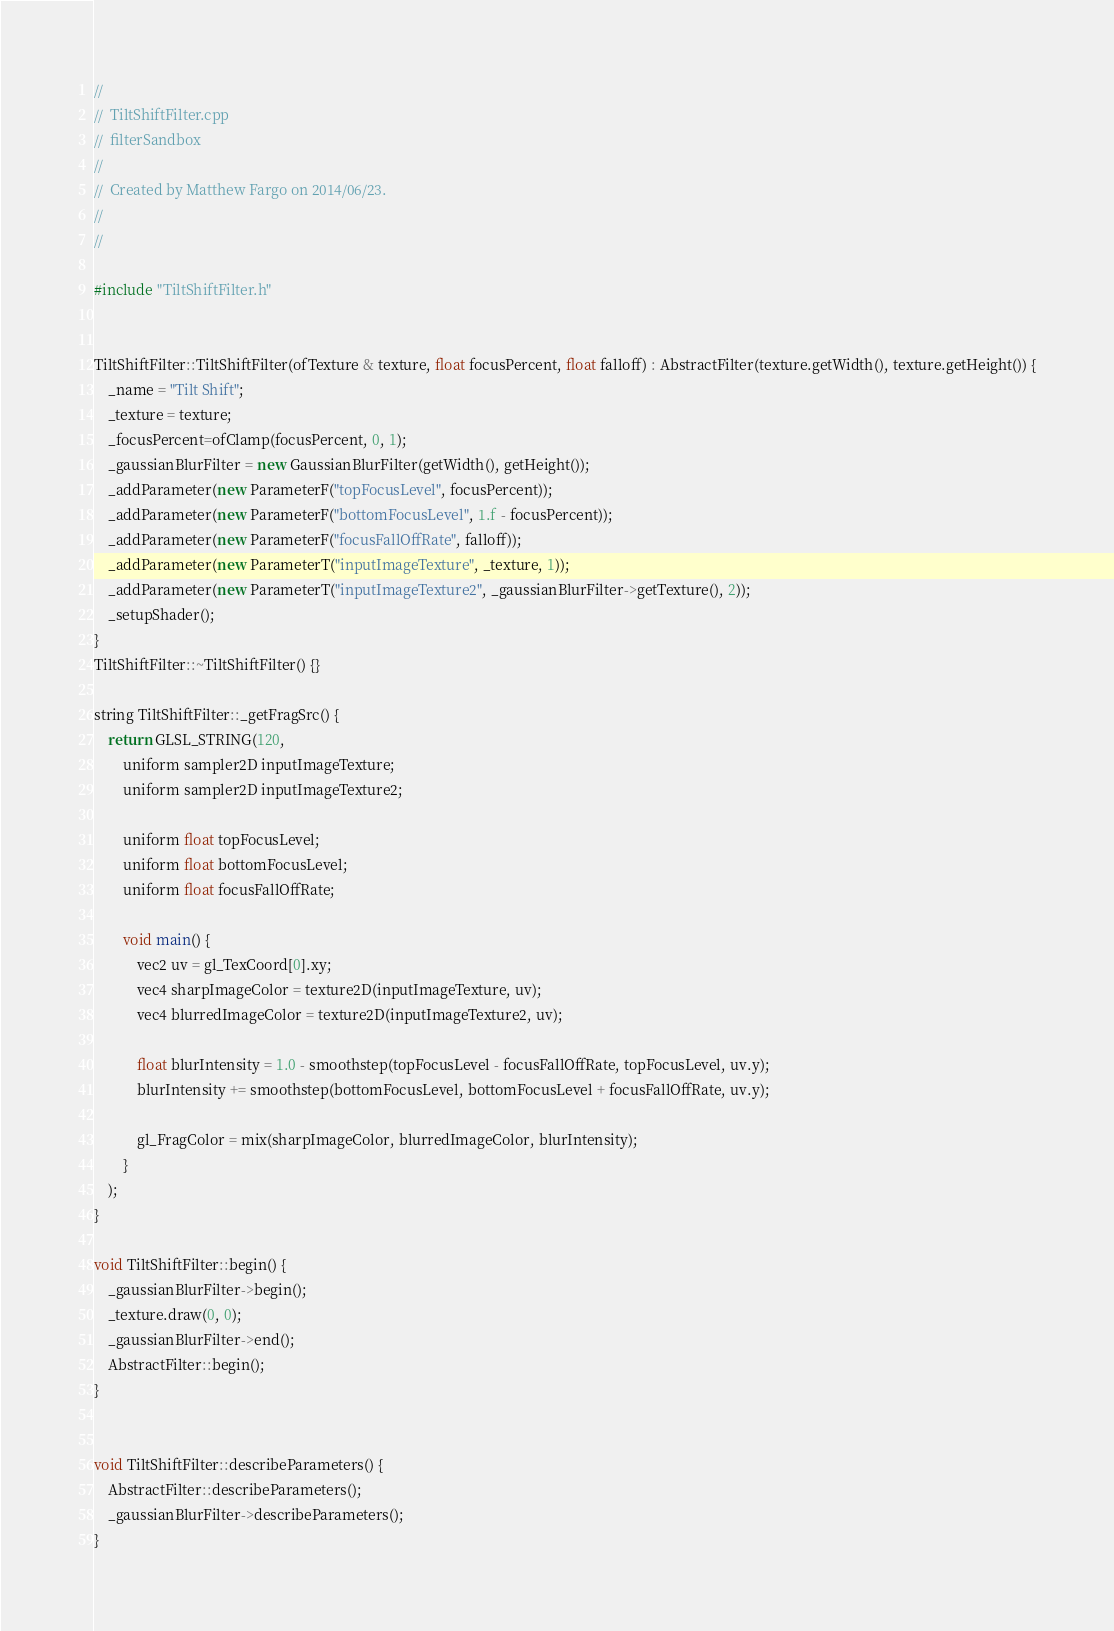Convert code to text. <code><loc_0><loc_0><loc_500><loc_500><_C++_>//
//  TiltShiftFilter.cpp
//  filterSandbox
//
//  Created by Matthew Fargo on 2014/06/23.
//
//

#include "TiltShiftFilter.h"


TiltShiftFilter::TiltShiftFilter(ofTexture & texture, float focusPercent, float falloff) : AbstractFilter(texture.getWidth(), texture.getHeight()) {
    _name = "Tilt Shift";
    _texture = texture;
    _focusPercent=ofClamp(focusPercent, 0, 1);
    _gaussianBlurFilter = new GaussianBlurFilter(getWidth(), getHeight());
    _addParameter(new ParameterF("topFocusLevel", focusPercent));
    _addParameter(new ParameterF("bottomFocusLevel", 1.f - focusPercent));
    _addParameter(new ParameterF("focusFallOffRate", falloff));
    _addParameter(new ParameterT("inputImageTexture", _texture, 1));
    _addParameter(new ParameterT("inputImageTexture2", _gaussianBlurFilter->getTexture(), 2));
    _setupShader();
}
TiltShiftFilter::~TiltShiftFilter() {}

string TiltShiftFilter::_getFragSrc() {
    return GLSL_STRING(120,
        uniform sampler2D inputImageTexture;
        uniform sampler2D inputImageTexture2;

        uniform float topFocusLevel;
        uniform float bottomFocusLevel;
        uniform float focusFallOffRate;

        void main() {
            vec2 uv = gl_TexCoord[0].xy;
            vec4 sharpImageColor = texture2D(inputImageTexture, uv);
            vec4 blurredImageColor = texture2D(inputImageTexture2, uv);
            
            float blurIntensity = 1.0 - smoothstep(topFocusLevel - focusFallOffRate, topFocusLevel, uv.y);
            blurIntensity += smoothstep(bottomFocusLevel, bottomFocusLevel + focusFallOffRate, uv.y);
            
            gl_FragColor = mix(sharpImageColor, blurredImageColor, blurIntensity);
        }
    );
}

void TiltShiftFilter::begin() {
    _gaussianBlurFilter->begin();
    _texture.draw(0, 0);
    _gaussianBlurFilter->end();
    AbstractFilter::begin();
}


void TiltShiftFilter::describeParameters() {
    AbstractFilter::describeParameters();
    _gaussianBlurFilter->describeParameters();
}</code> 